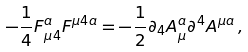Convert formula to latex. <formula><loc_0><loc_0><loc_500><loc_500>- \frac { 1 } { 4 } F _ { \mu 4 } ^ { a } F ^ { \mu 4 a } = - \frac { 1 } { 2 } \partial _ { 4 } A _ { \mu } ^ { a } \partial ^ { 4 } A ^ { \mu a } \, ,</formula> 